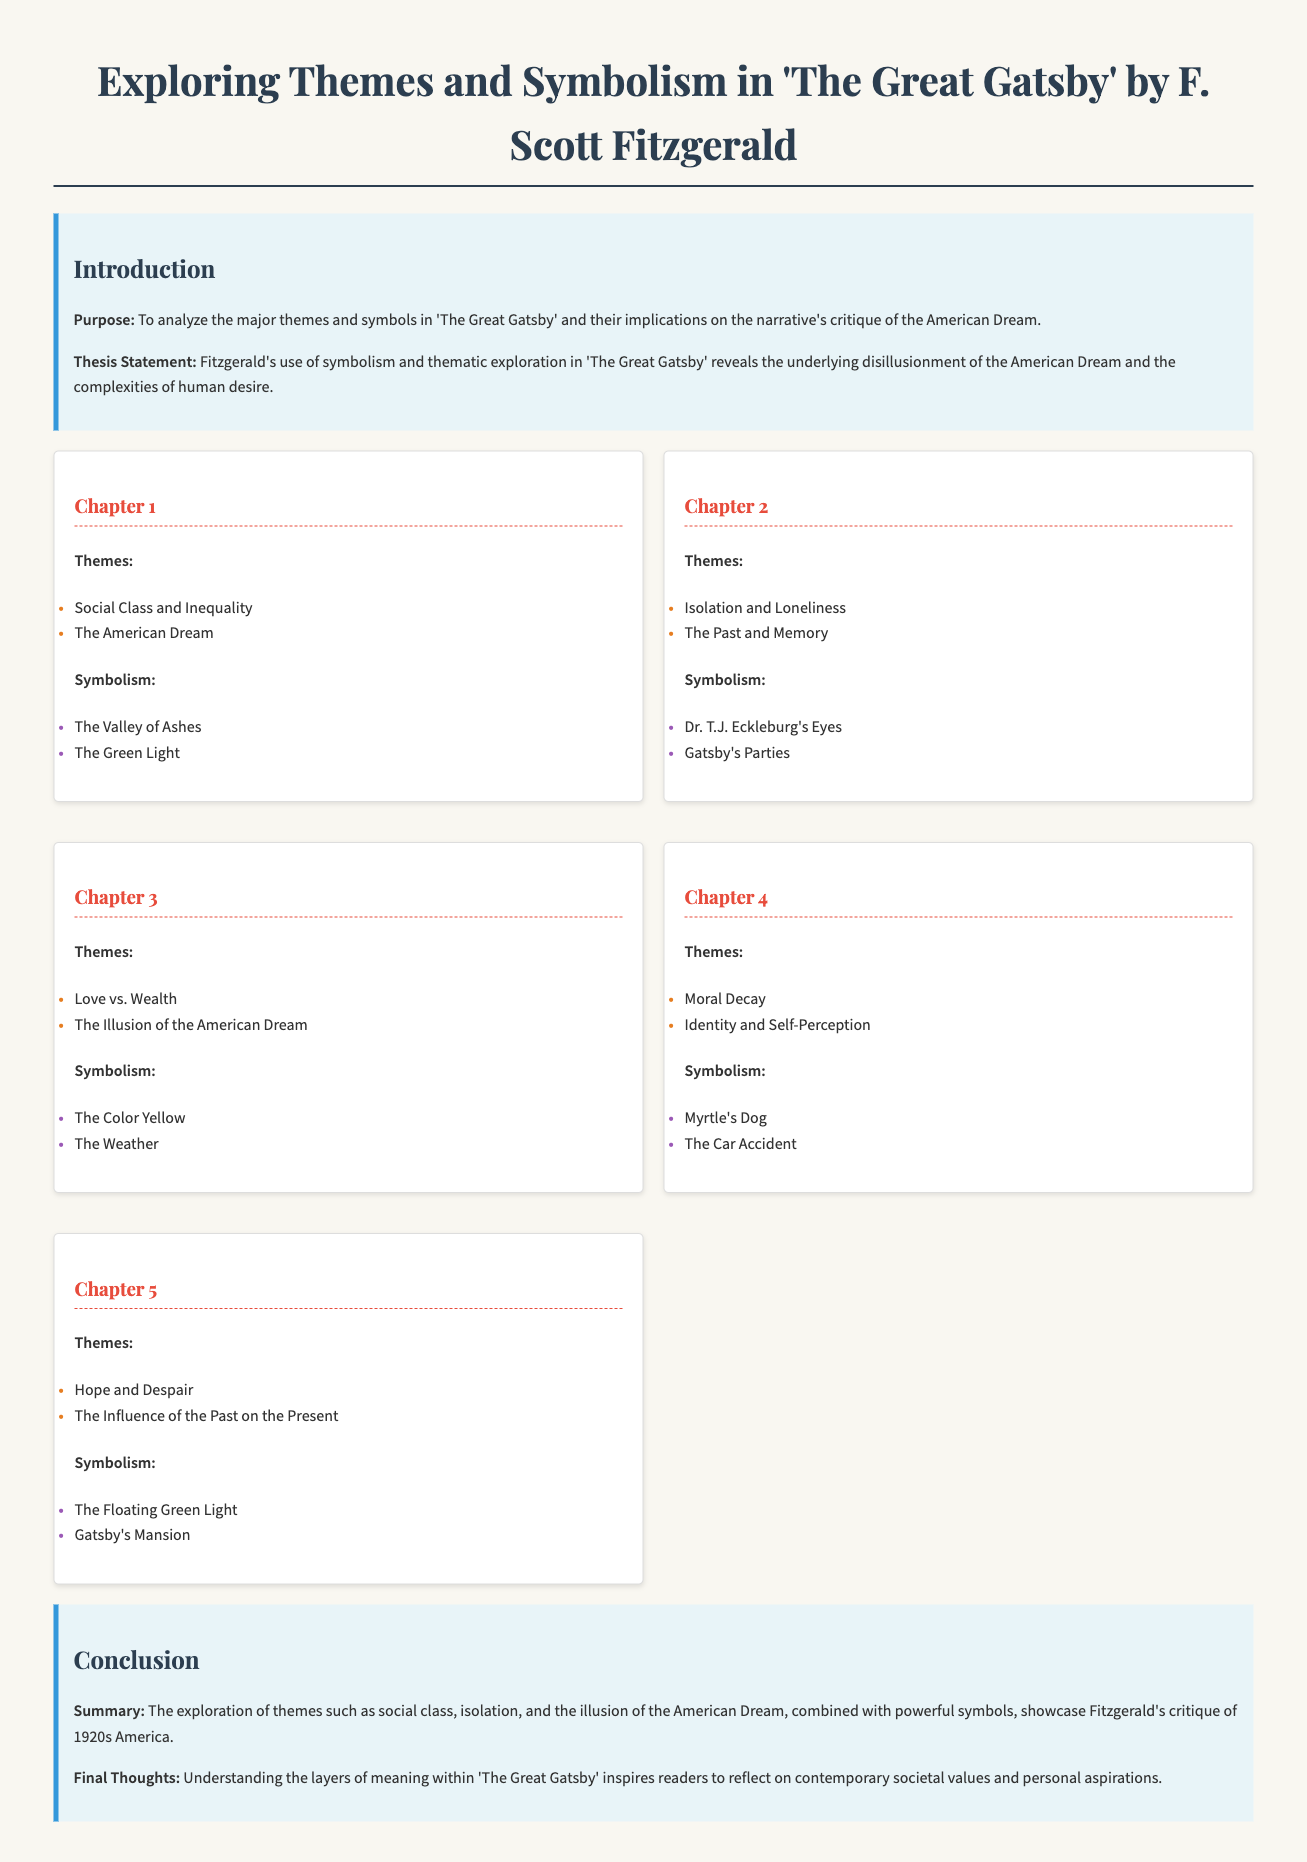what is the purpose of the essay? The purpose is to analyze the major themes and symbols in 'The Great Gatsby' and their implications on the narrative's critique of the American Dream.
Answer: to analyze themes and symbols what is the thesis statement of the essay? The thesis statement outlines Fitzgerald's use of symbolism and thematic exploration in 'The Great Gatsby.'
Answer: reveals disillusionment of the American Dream how many chapters are discussed in total? The document contains a breakdown of five chapters.
Answer: 5 which symbol is associated with Chapter 1? Chapter 1 discusses two symbols, one of which is the Valley of Ashes.
Answer: The Valley of Ashes what theme is explored in Chapter 4? Chapter 4 explores the theme of Moral Decay.
Answer: Moral Decay how does Fitzgerald critique the 1920s America according to the conclusion? The conclusion states that Fitzgerald critiques America through themes and symbols.
Answer: critique of 1920s America what color symbolizes hope in Chapter 5? The color that symbolizes hope in Chapter 5 is the Floating Green Light.
Answer: Floating Green Light what theme relates to Gatsby's parties in Chapter 2? In Chapter 2, the theme related to Gatsby's parties is Isolation and Loneliness.
Answer: Isolation and Loneliness 